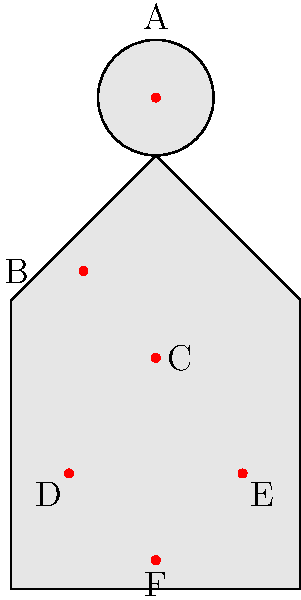In the illustration above, which labeled stress point is most likely to be affected by prolonged periods of sitting and reading legal documents? To answer this question, we need to consider the biomechanical stress points on a lawyer's body during a typical workday, particularly focusing on activities like sitting and reading legal documents for extended periods. Let's analyze each labeled point:

1. Point A (Head): While reading can cause eye strain, it's not the primary biomechanical stress point for prolonged sitting.

2. Point B (Neck): Prolonged reading can cause neck strain, especially if documents are placed on a desk, causing the neck to bend forward. However, this is not the most significant stress point for extended sitting.

3. Point C (Lower back): This is the most likely area to be affected by prolonged sitting. The lumbar region of the spine bears a significant load when seated, and poor posture can lead to increased stress on the lower back.

4. Points D and E (Wrists): While these can be stressed during typing or writing, they are not primarily affected by the act of sitting and reading.

5. Point F (Lower body): This area can be affected by prolonged sitting due to reduced circulation, but it's not as directly impacted as the lower back.

Given the nature of prolonged sitting and reading, the lower back (Point C) is the most likely to be affected due to the constant pressure and potential for poor posture over extended periods.
Answer: C (Lower back) 